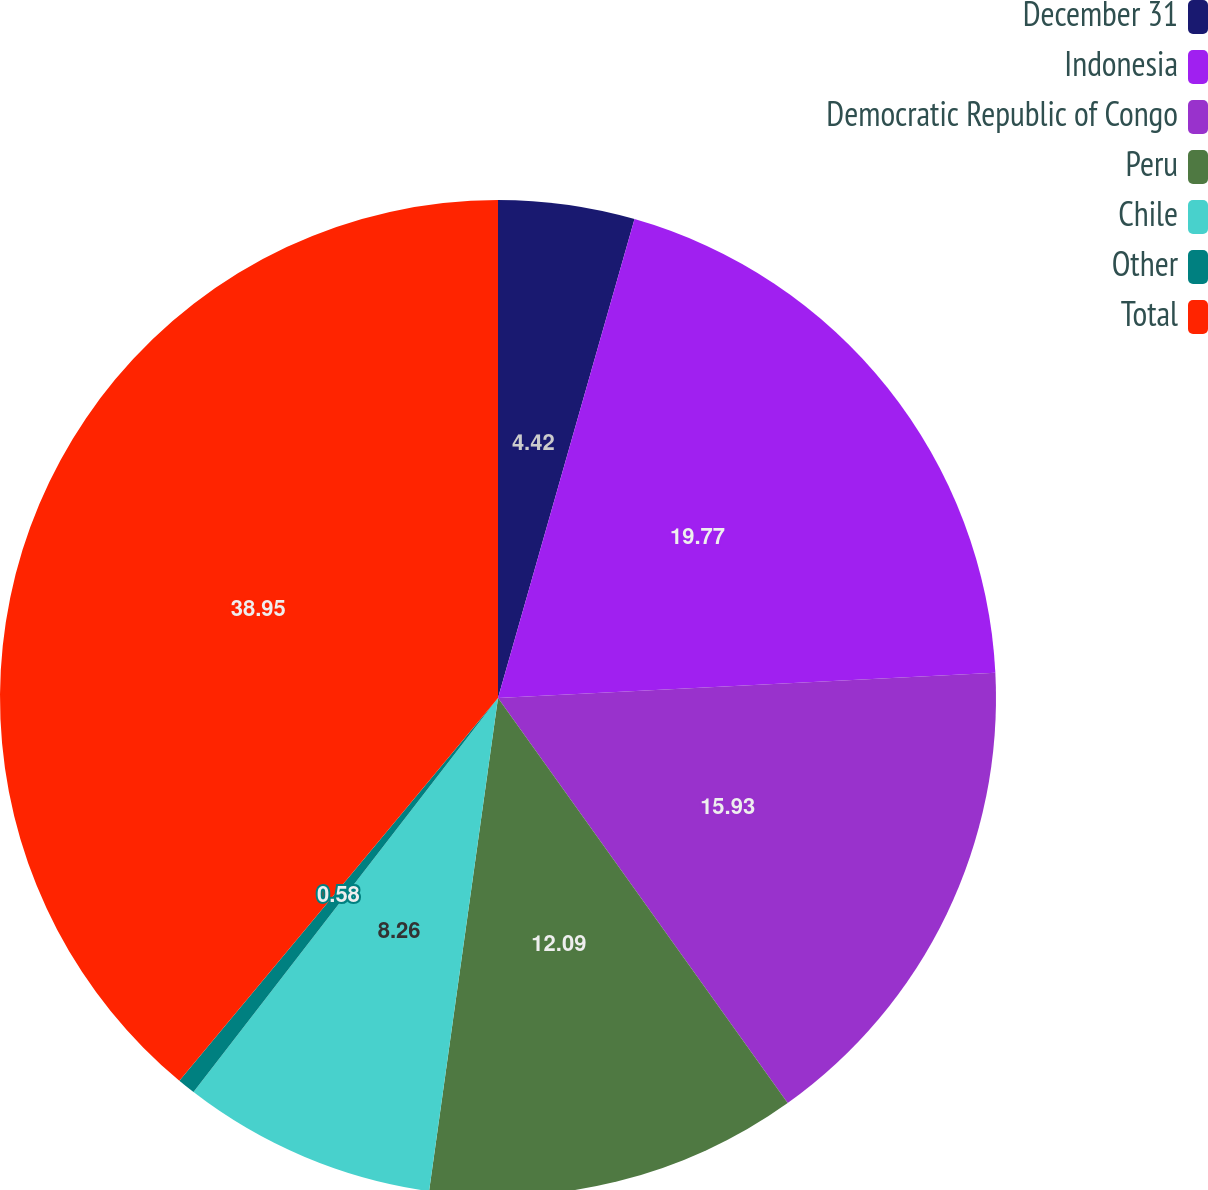Convert chart. <chart><loc_0><loc_0><loc_500><loc_500><pie_chart><fcel>December 31<fcel>Indonesia<fcel>Democratic Republic of Congo<fcel>Peru<fcel>Chile<fcel>Other<fcel>Total<nl><fcel>4.42%<fcel>19.77%<fcel>15.93%<fcel>12.09%<fcel>8.26%<fcel>0.58%<fcel>38.95%<nl></chart> 